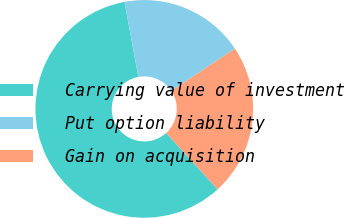Convert chart to OTSL. <chart><loc_0><loc_0><loc_500><loc_500><pie_chart><fcel>Carrying value of investment<fcel>Put option liability<fcel>Gain on acquisition<nl><fcel>58.86%<fcel>18.56%<fcel>22.59%<nl></chart> 